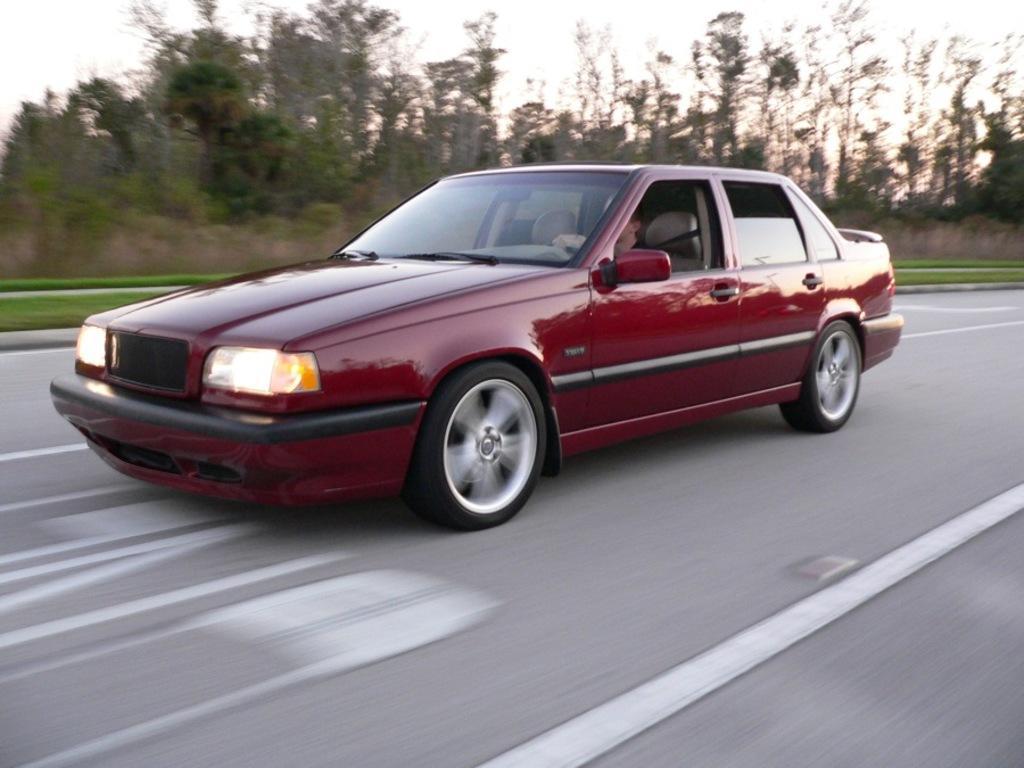How would you summarize this image in a sentence or two? In this image we can see a person driving a car, which is on the road, there are trees, plants, grass, also we can see the sky. 